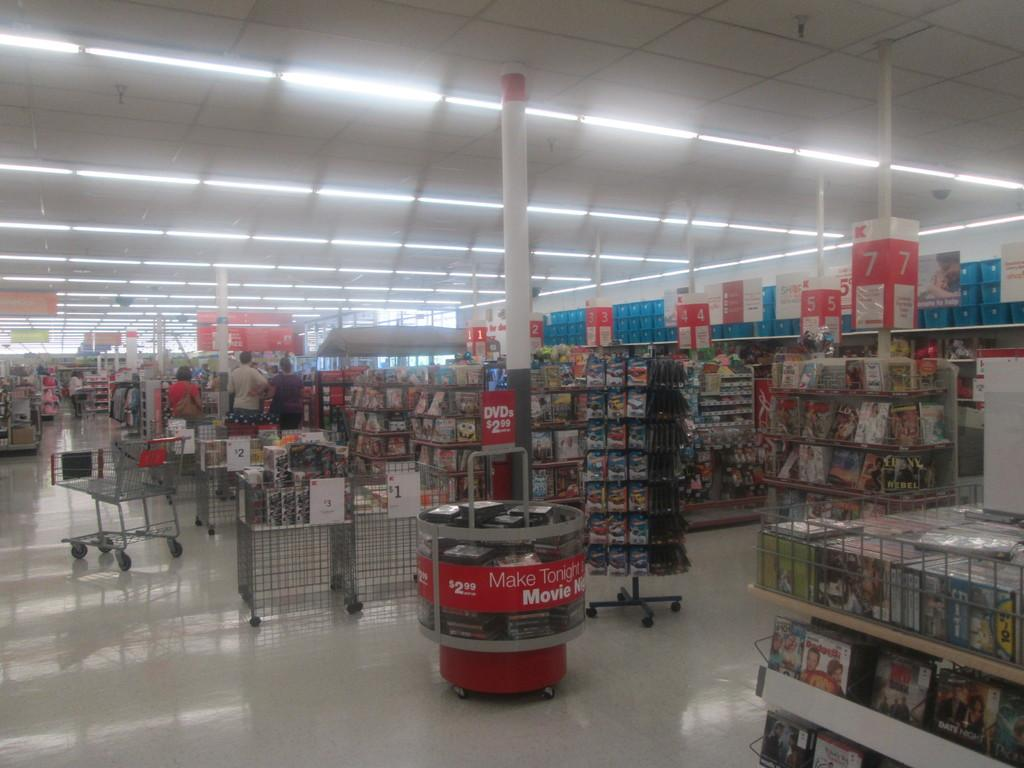<image>
Share a concise interpretation of the image provided. DVDs are sold for 2.99 in the display case. 